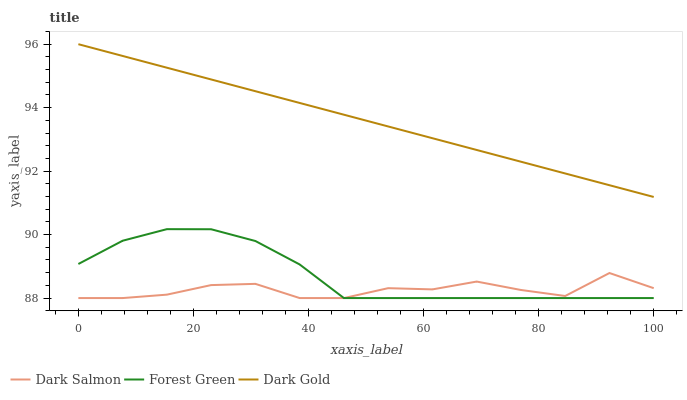Does Dark Salmon have the minimum area under the curve?
Answer yes or no. Yes. Does Dark Gold have the maximum area under the curve?
Answer yes or no. Yes. Does Dark Gold have the minimum area under the curve?
Answer yes or no. No. Does Dark Salmon have the maximum area under the curve?
Answer yes or no. No. Is Dark Gold the smoothest?
Answer yes or no. Yes. Is Dark Salmon the roughest?
Answer yes or no. Yes. Is Dark Salmon the smoothest?
Answer yes or no. No. Is Dark Gold the roughest?
Answer yes or no. No. Does Forest Green have the lowest value?
Answer yes or no. Yes. Does Dark Gold have the lowest value?
Answer yes or no. No. Does Dark Gold have the highest value?
Answer yes or no. Yes. Does Dark Salmon have the highest value?
Answer yes or no. No. Is Forest Green less than Dark Gold?
Answer yes or no. Yes. Is Dark Gold greater than Dark Salmon?
Answer yes or no. Yes. Does Dark Salmon intersect Forest Green?
Answer yes or no. Yes. Is Dark Salmon less than Forest Green?
Answer yes or no. No. Is Dark Salmon greater than Forest Green?
Answer yes or no. No. Does Forest Green intersect Dark Gold?
Answer yes or no. No. 